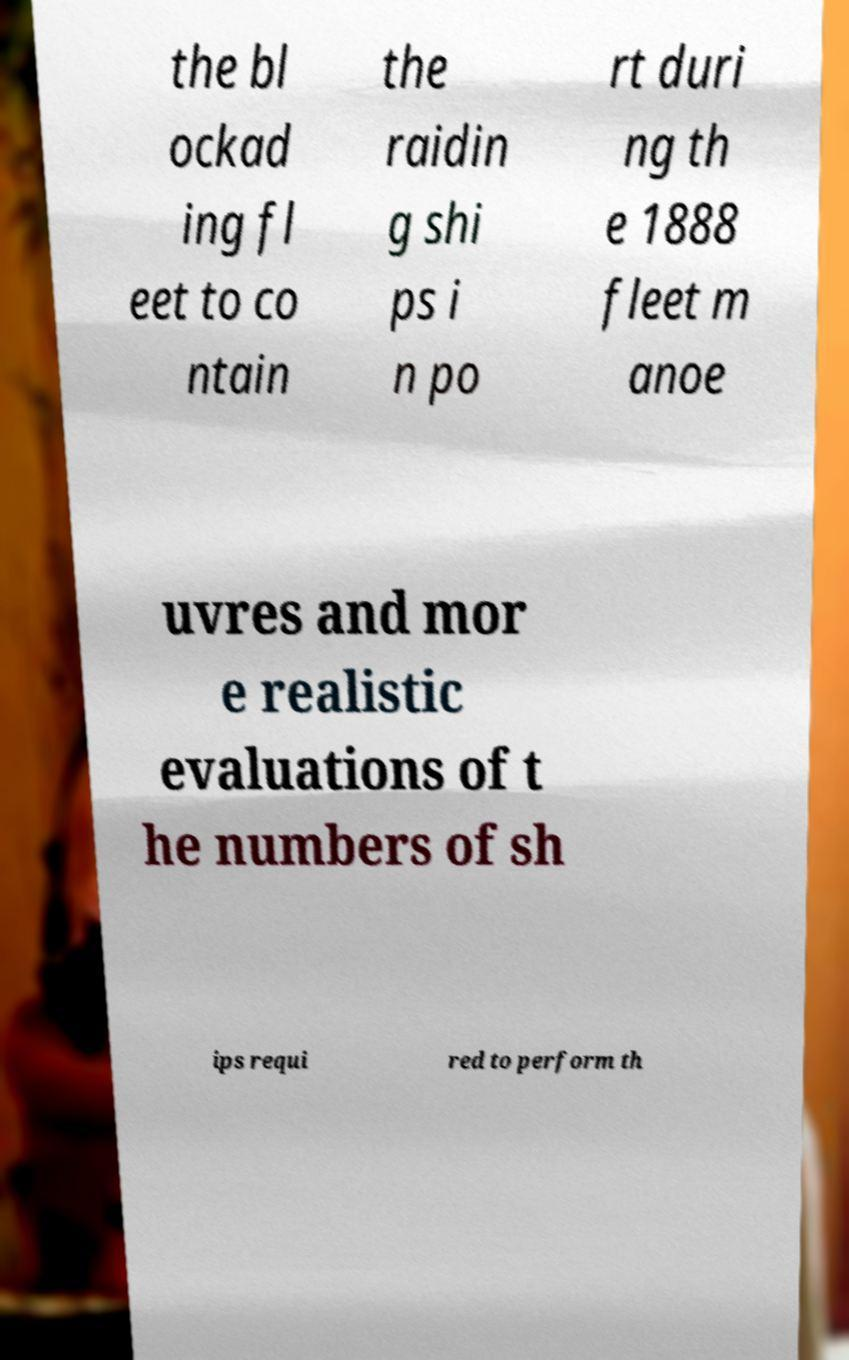I need the written content from this picture converted into text. Can you do that? the bl ockad ing fl eet to co ntain the raidin g shi ps i n po rt duri ng th e 1888 fleet m anoe uvres and mor e realistic evaluations of t he numbers of sh ips requi red to perform th 